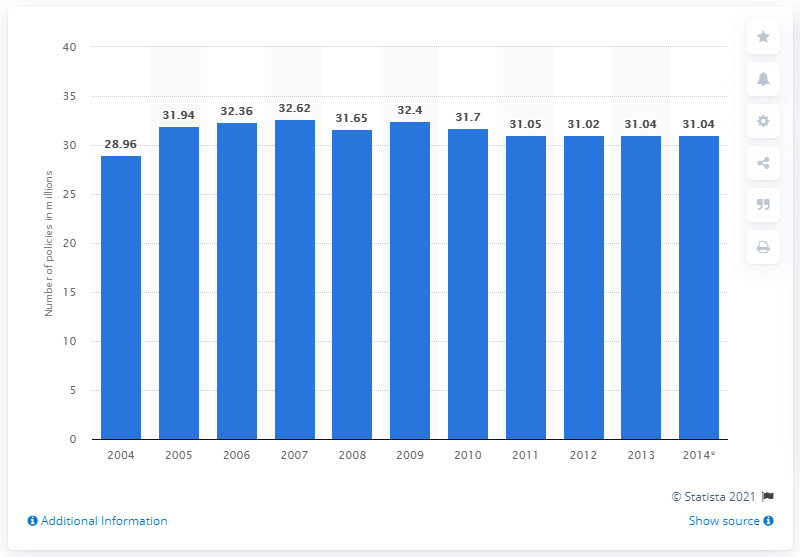Draw attention to some important aspects in this diagram. In 2013, there were approximately 31.04 million vehicles with motor insurance coverage in the United Kingdom. 